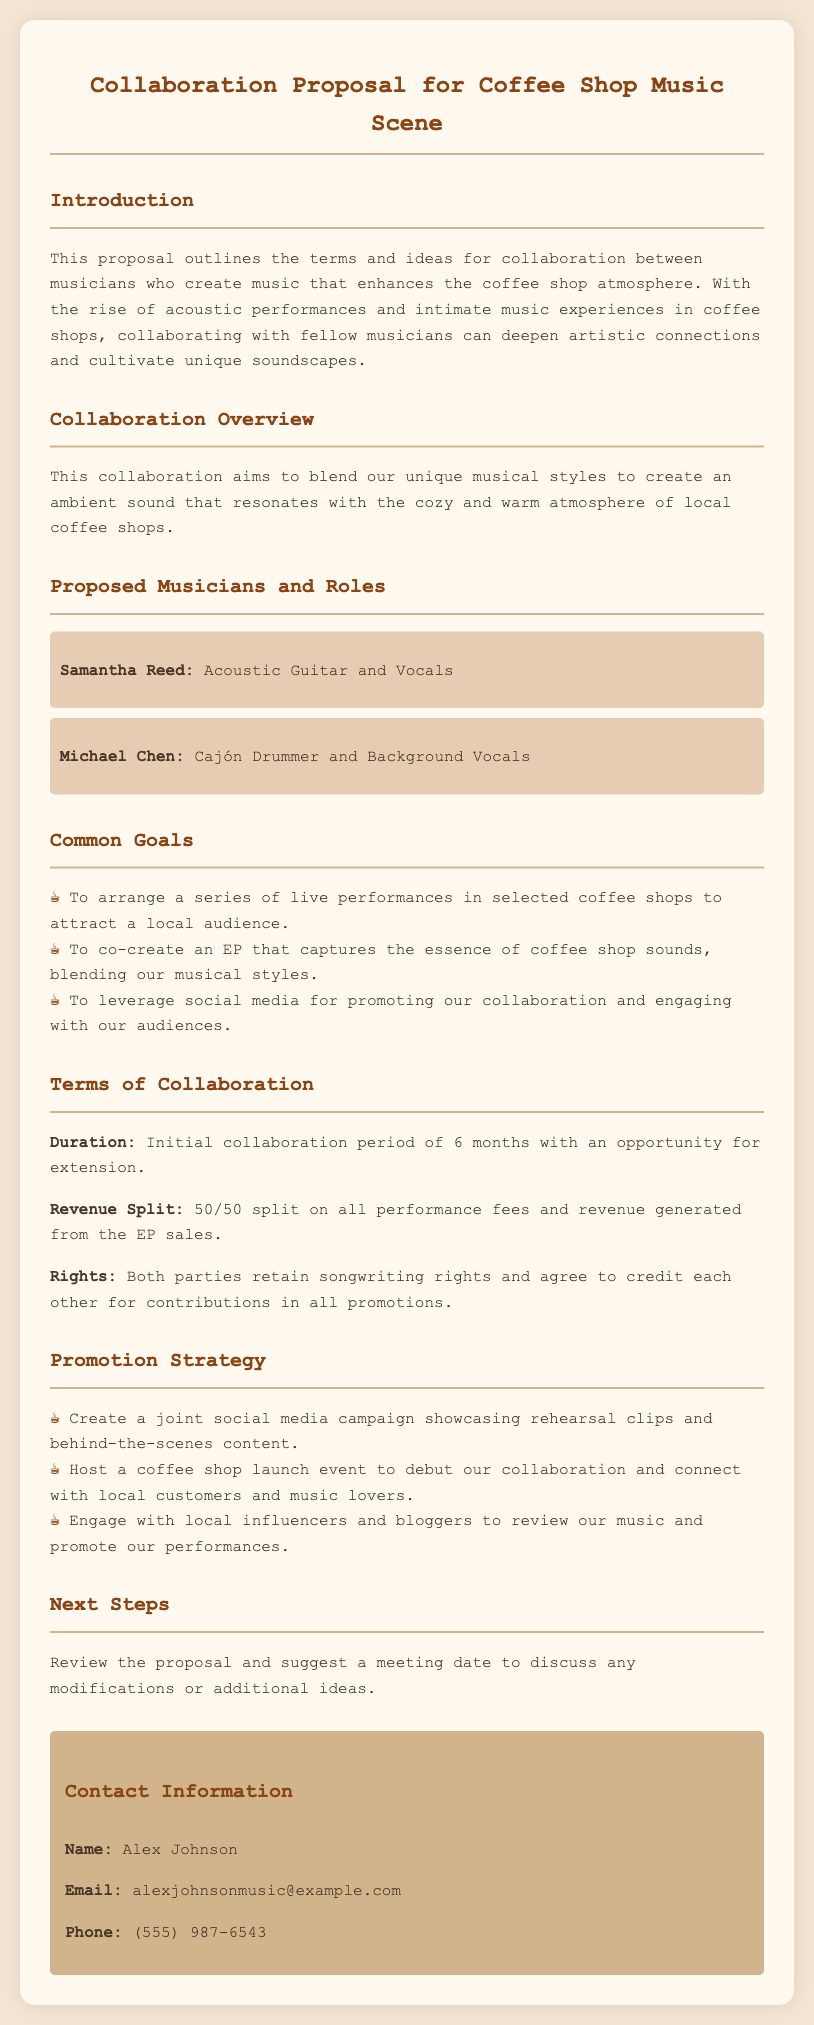What is the name of the first proposed musician? The first proposed musician is specifically named in the document, which is Samantha Reed.
Answer: Samantha Reed What instrument does Michael Chen play? Michael Chen's role and instrument are detailed in the document as Cajón Drummer and Background Vocals.
Answer: Cajón Drummer What is the duration of the initial collaboration period? The duration of the initial collaboration is specified clearly in the document as 6 months.
Answer: 6 months What is the revenue split defined in the proposal? The revenue split for performance fees and EP sales is clearly mentioned in the document as 50/50.
Answer: 50/50 What type of campaign is planned for promotion? The structured promotion strategy includes a specific type of campaign mentioned in the document, which is a joint social media campaign.
Answer: Joint social media campaign What are the common goals for the collaboration? Common goals that unite the collaborators are outlined in a concise list in the document and include arranging live performances.
Answer: Arrange live performances Who should be contacted for more information? The contact information includes a specific name, which is Alex Johnson as mentioned in the document.
Answer: Alex Johnson What is one of the ways to engage with audiences mentioned in the document? The document includes various strategies for engagement, one of which is hosting a coffee shop launch event.
Answer: Hosting a coffee shop launch event What is the purpose of this proposal? The proposal outlines the purpose for collaboration among musicians, specifically to enhance the coffee shop atmosphere.
Answer: Enhance the coffee shop atmosphere 